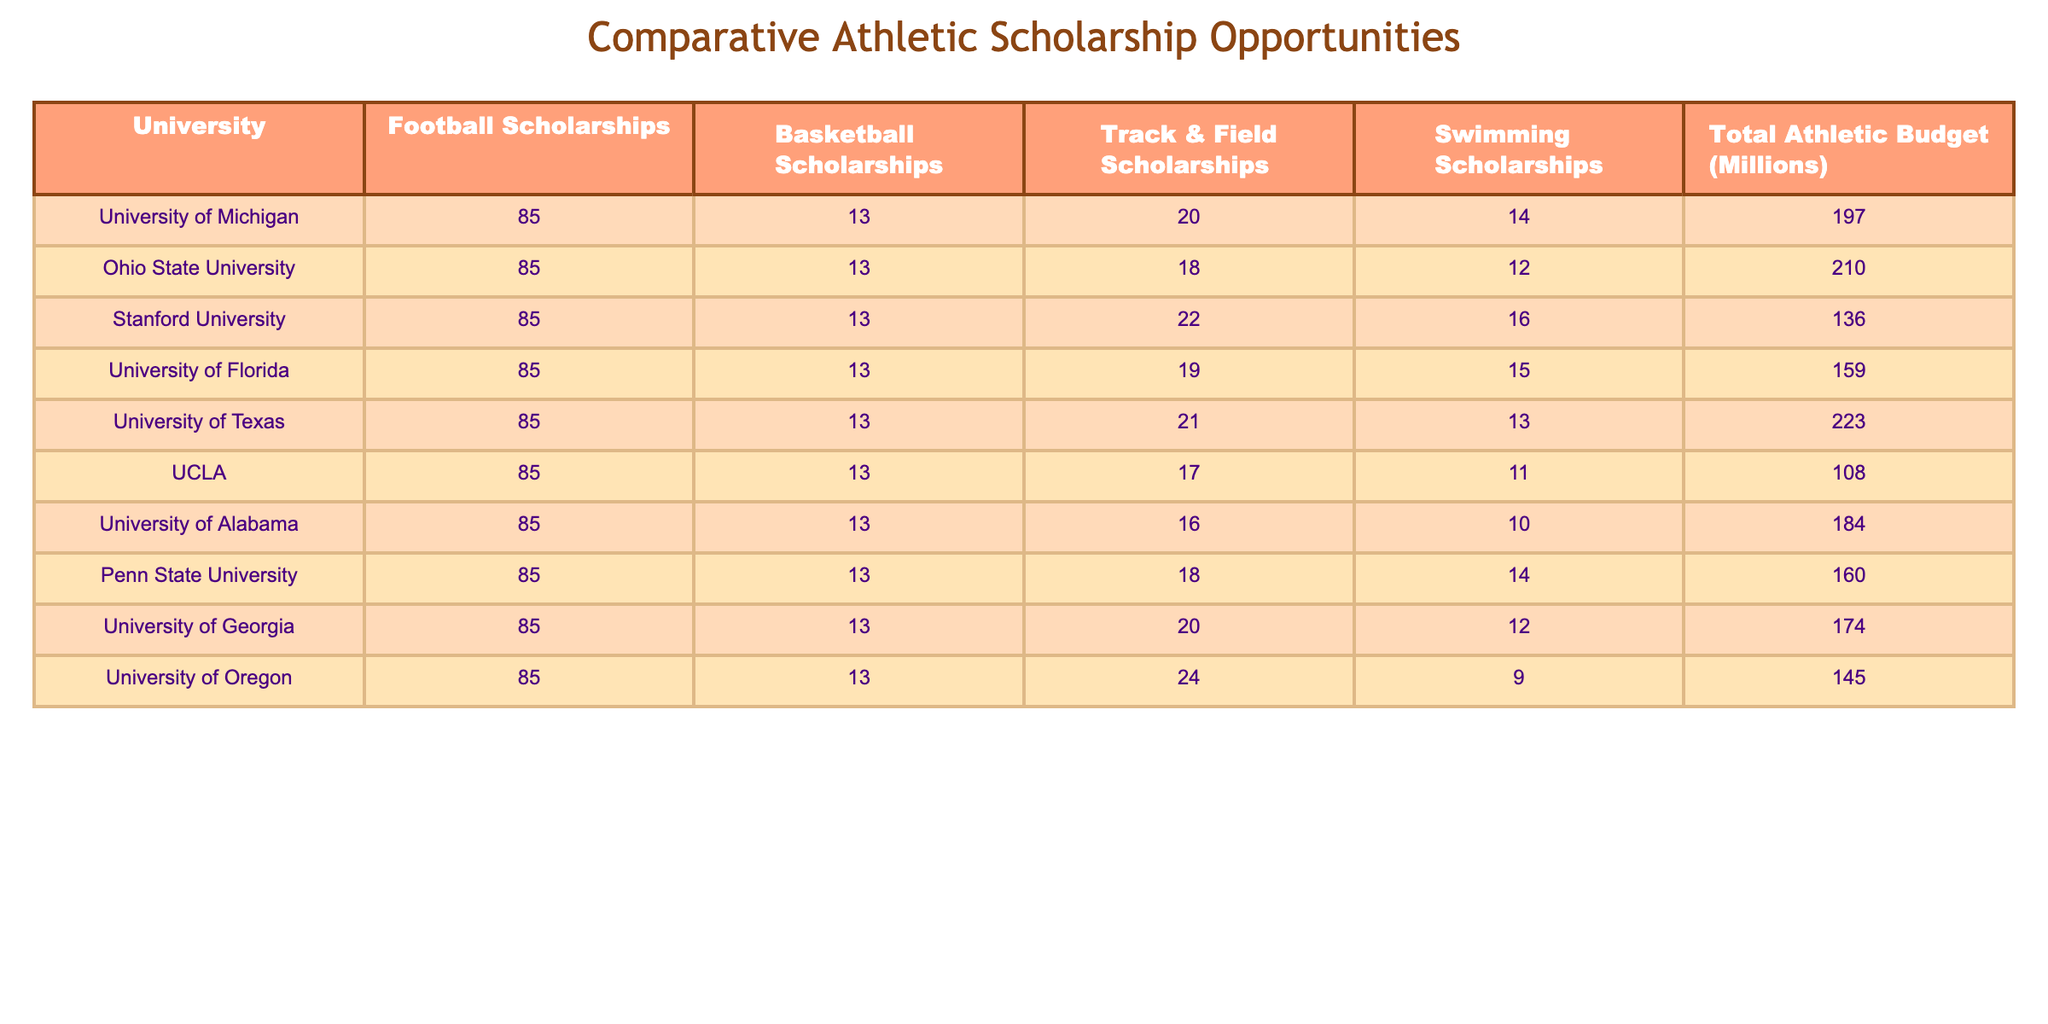What is the total number of football scholarships available at the University of Florida? The table shows the number of football scholarships for each university. For the University of Florida, it states that there are 85 football scholarships available.
Answer: 85 How many swimming scholarships does the University of Georgia offer? Referring to the table under the swimming scholarships column, the University of Georgia has 12 swimming scholarships available.
Answer: 12 Which university has the highest total athletic budget? By comparing the total athletic budget values in the last column, Ohio State University has the highest total athletic budget at 210 million.
Answer: Ohio State University What is the combined total of track & field scholarships for the University of Texas and Stanford University? The total track & field scholarships available are 21 for the University of Texas and 22 for Stanford University. Adding these gives 21 + 22 = 43 combined track & field scholarships.
Answer: 43 Is it true that the University of Alabama offers more swimming scholarships than UCLA? The table lists 10 swimming scholarships for the University of Alabama and 11 for UCLA. Since 10 is less than 11, the statement is false.
Answer: No What is the average total athletic budget of all universities listed in the table? The total athletic budgets listed are 197, 210, 136, 159, 223, 108, 184, 160, 174, 145. Summing these values gives 1,575. Dividing by the number of universities (10) gives an average of 1,575 / 10 = 157.5 million.
Answer: 157.5 Which university has the lowest track & field scholarships? By inspecting the track & field scholarship column, UCLA has the lowest number of track & field scholarships with 17.
Answer: UCLA How many more football scholarships does Ohio State University offer compared to UCLA? Ohio State University has 85 football scholarships while UCLA also has 85. The difference is 85 - 85 = 0.
Answer: 0 Which two universities have the same number of basketball scholarships? Looking at the basketball scholarships column, all universities have 13 basketball scholarships. Therefore, any two universities can be chosen; for example, University of Michigan and University of Florida.
Answer: Any two universities What is the total number of swimming scholarships across all the universities? Adding the swimming scholarships: 14 + 12 + 16 + 15 + 13 + 11 + 10 + 14 + 12 + 9 = 136 total swimming scholarships across all universities.
Answer: 136 